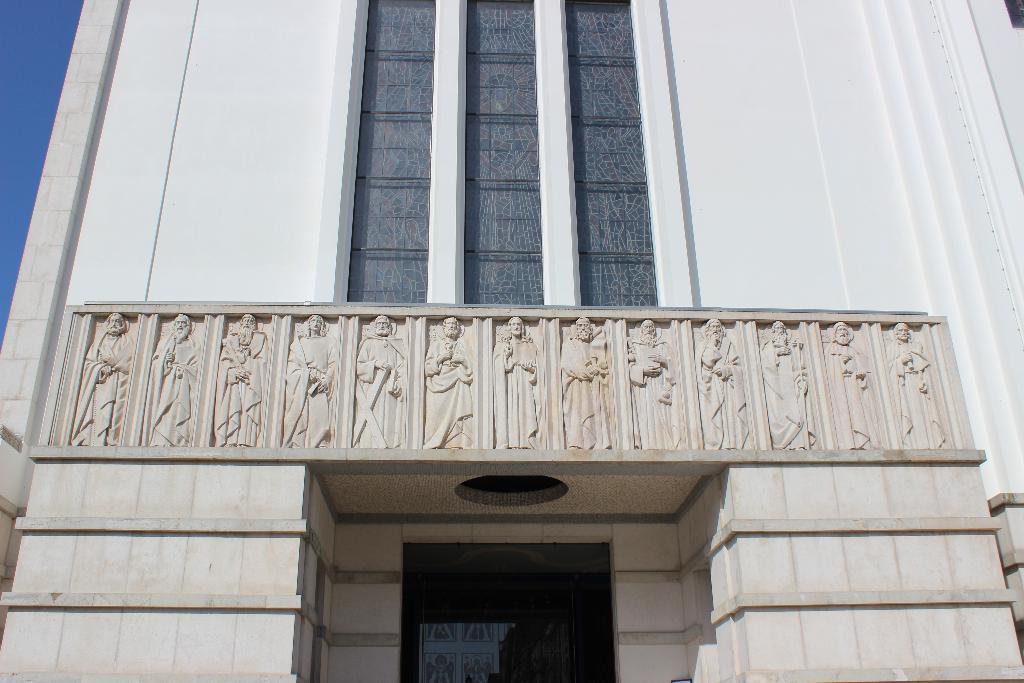In one or two sentences, can you explain what this image depicts? This is a building and we can see glass doors,sculptures on the wall and sky. 